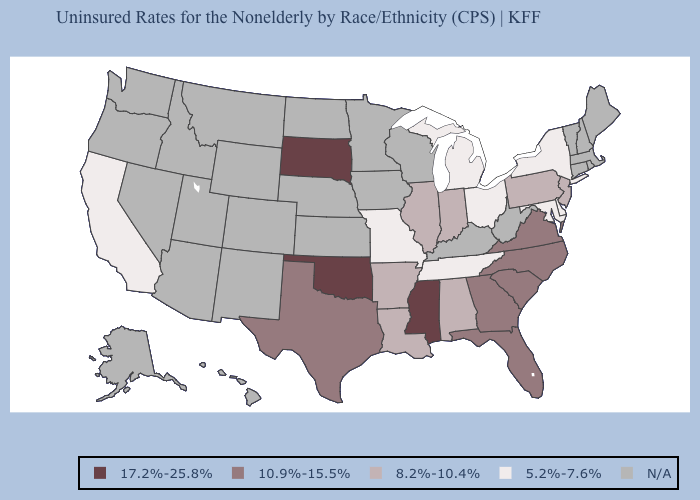What is the value of Wisconsin?
Short answer required. N/A. Does South Dakota have the highest value in the MidWest?
Quick response, please. Yes. Which states hav the highest value in the South?
Quick response, please. Mississippi, Oklahoma. Is the legend a continuous bar?
Short answer required. No. What is the value of Kansas?
Be succinct. N/A. Among the states that border Ohio , does Michigan have the highest value?
Keep it brief. No. Which states have the lowest value in the USA?
Short answer required. California, Delaware, Maryland, Michigan, Missouri, New York, Ohio, Tennessee. Is the legend a continuous bar?
Answer briefly. No. Name the states that have a value in the range 5.2%-7.6%?
Be succinct. California, Delaware, Maryland, Michigan, Missouri, New York, Ohio, Tennessee. What is the lowest value in the Northeast?
Quick response, please. 5.2%-7.6%. Does Illinois have the highest value in the MidWest?
Be succinct. No. Name the states that have a value in the range 5.2%-7.6%?
Be succinct. California, Delaware, Maryland, Michigan, Missouri, New York, Ohio, Tennessee. What is the value of Utah?
Give a very brief answer. N/A. 